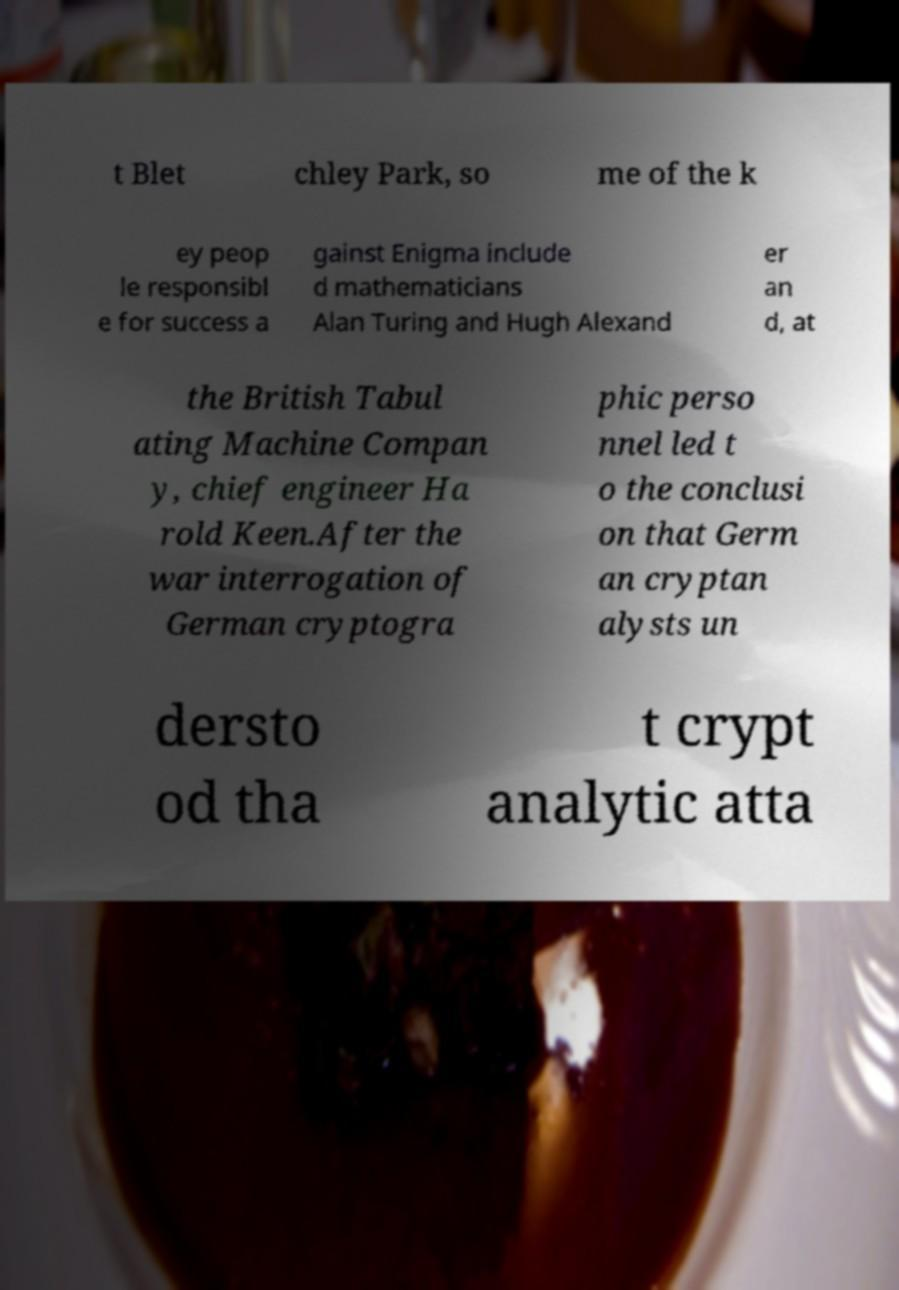What messages or text are displayed in this image? I need them in a readable, typed format. t Blet chley Park, so me of the k ey peop le responsibl e for success a gainst Enigma include d mathematicians Alan Turing and Hugh Alexand er an d, at the British Tabul ating Machine Compan y, chief engineer Ha rold Keen.After the war interrogation of German cryptogra phic perso nnel led t o the conclusi on that Germ an cryptan alysts un dersto od tha t crypt analytic atta 